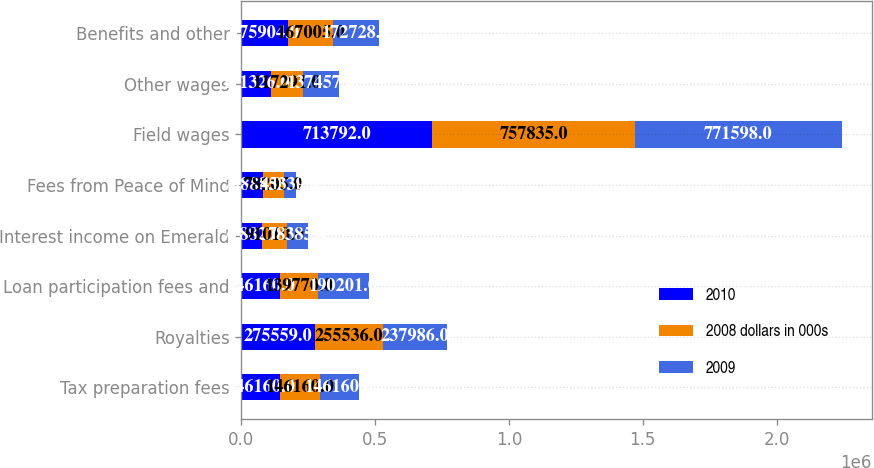Convert chart. <chart><loc_0><loc_0><loc_500><loc_500><stacked_bar_chart><ecel><fcel>Tax preparation fees<fcel>Royalties<fcel>Loan participation fees and<fcel>Interest income on Emerald<fcel>Fees from Peace of Mind<fcel>Field wages<fcel>Other wages<fcel>Benefits and other<nl><fcel>2010<fcel>146160<fcel>275559<fcel>146160<fcel>77882<fcel>79888<fcel>713792<fcel>111326<fcel>175904<nl><fcel>2008 dollars in 000s<fcel>146160<fcel>255536<fcel>139770<fcel>91010<fcel>78205<fcel>757835<fcel>117291<fcel>167005<nl><fcel>2009<fcel>146160<fcel>237986<fcel>190201<fcel>78385<fcel>45339<fcel>771598<fcel>137457<fcel>172728<nl></chart> 